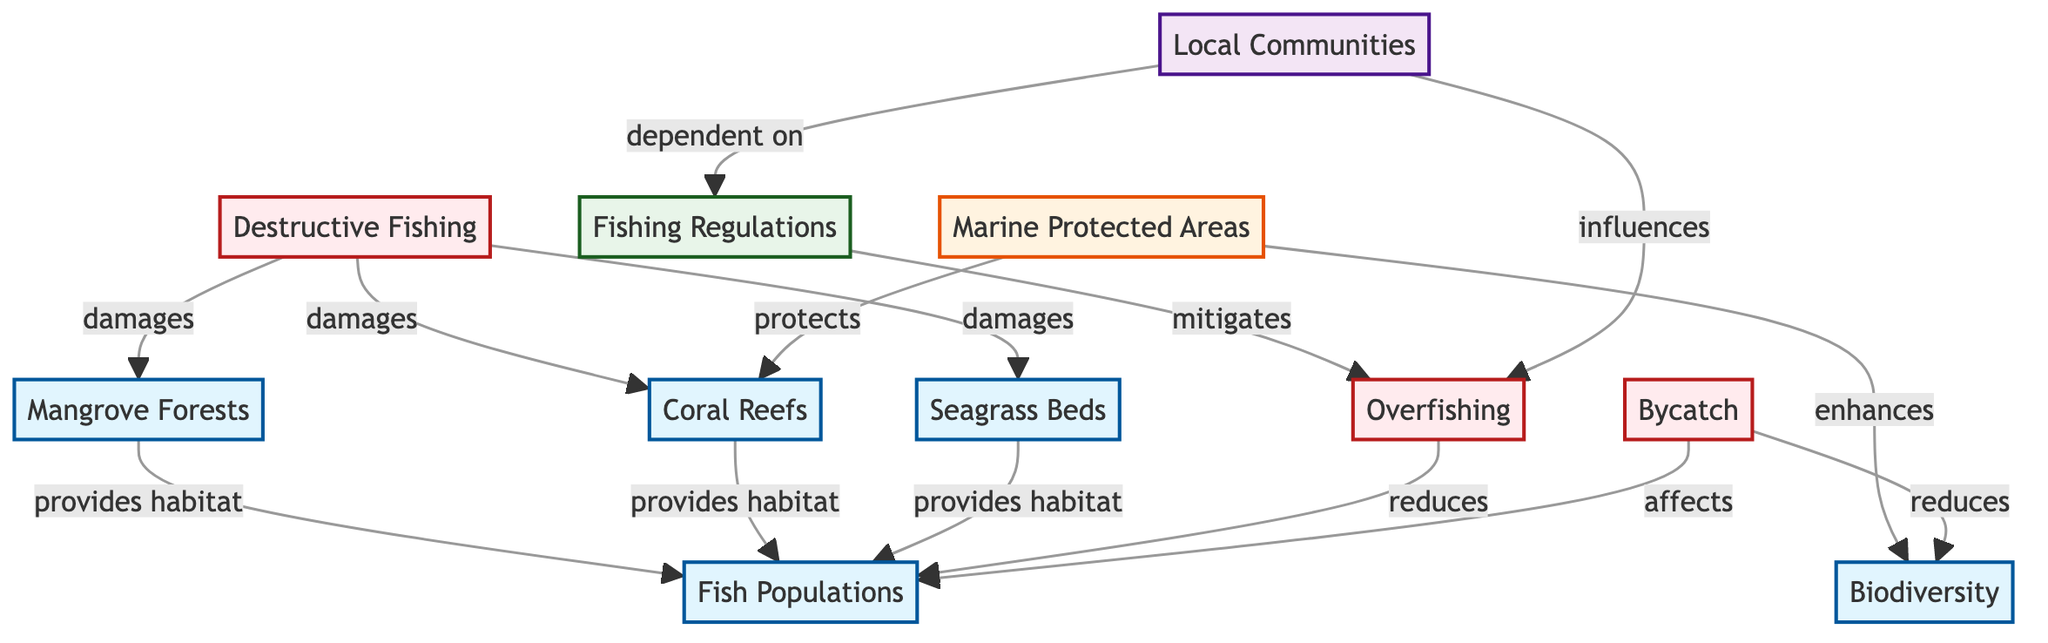What's the total number of nodes in the diagram? The diagram has 11 nodes as listed within the "nodes" section. Each entry represents a unique ecosystem component, fishing practice, management strategy, conservation effort, or stakeholder.
Answer: 11 How many edges connect to Mangrove Forests? Mangrove Forests is connected to Fish Populations by providing habitat. It is also impacted by Destructive Fishing which damages it. Thus, it has a total of 2 edges.
Answer: 2 What is the relationship between Coral Reefs and Fish Populations? Coral Reefs provides habitat for Fish Populations, establishing a direct connection where Coral Reefs supports the survival of fish.
Answer: provides habitat Which fishing practice is mitigated by Fishing Regulations? Fishing Regulations mitigate Overfishing, as indicated in the edge that shows a protective relationship where fishing regulations attempt to alleviate pressures on fish populations due to overfishing.
Answer: Overfishing How does Bycatch affect Biodiversity? Bycatch reduces Biodiversity, which is evident from the edge that connects Bycatch to Biodiversity, illustrating that unwanted catches can negatively impact the variety of life in the ecosystem.
Answer: reduces What do Marine Protected Areas enhance? Marine Protected Areas enhance Biodiversity. This is established through the direct connection shown in the diagram, indicating that these areas contribute positively to the variety of life.
Answer: Biodiversity Which fishing practice damages all three ecosystem components: Coral Reefs, Mangrove Forests, and Seagrass Beds? Destructive Fishing damages Coral Reefs, Mangrove Forests, and Seagrass Beds as indicated by the edges connecting to all three nodes from Destructive Fishing.
Answer: Destructive Fishing What influences Overfishing? Local Communities influence Overfishing according to the edge that connects these two nodes, suggesting that the fishing practices of local communities affect the state of fish populations.
Answer: Local Communities How many conservation efforts are depicted in the diagram? The diagram shows 1 conservation effort, which is the Marine Protected Areas as specified under the conservation effort category in the nodes section.
Answer: 1 